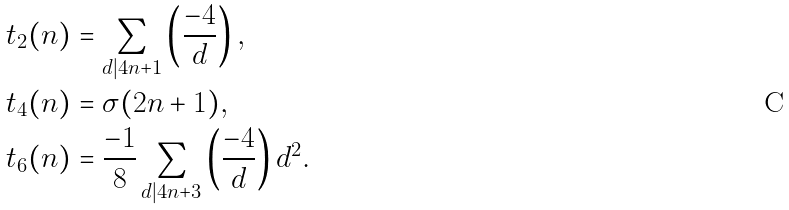Convert formula to latex. <formula><loc_0><loc_0><loc_500><loc_500>t _ { 2 } ( n ) & = \sum _ { d | 4 n + 1 } \left ( \frac { - 4 } { d } \right ) , \\ t _ { 4 } ( n ) & = \sigma ( 2 n + 1 ) , \\ t _ { 6 } ( n ) & = \frac { - 1 } { 8 } \sum _ { d | 4 n + 3 } \left ( \frac { - 4 } { d } \right ) d ^ { 2 } .</formula> 